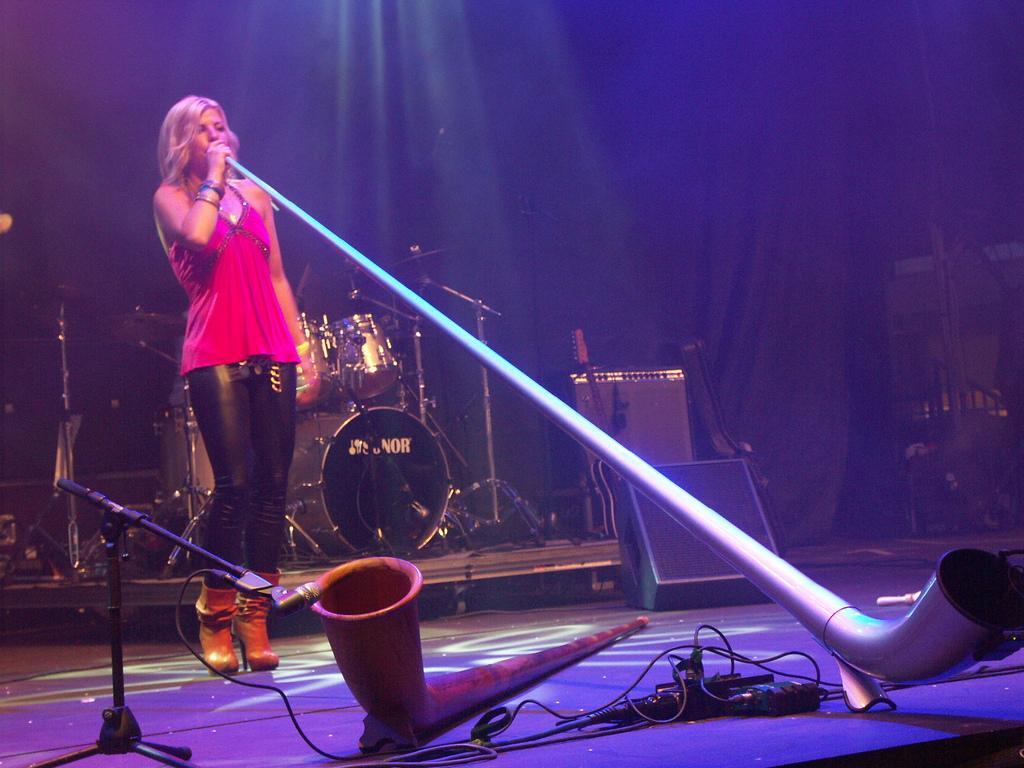How would you summarize this image in a sentence or two? In the background portion of the picture it's dark. In this picture we can see the musical instruments, devices and few objects on the platform. We can see a woman standing and she is holding an object. 